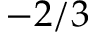Convert formula to latex. <formula><loc_0><loc_0><loc_500><loc_500>- 2 / 3</formula> 